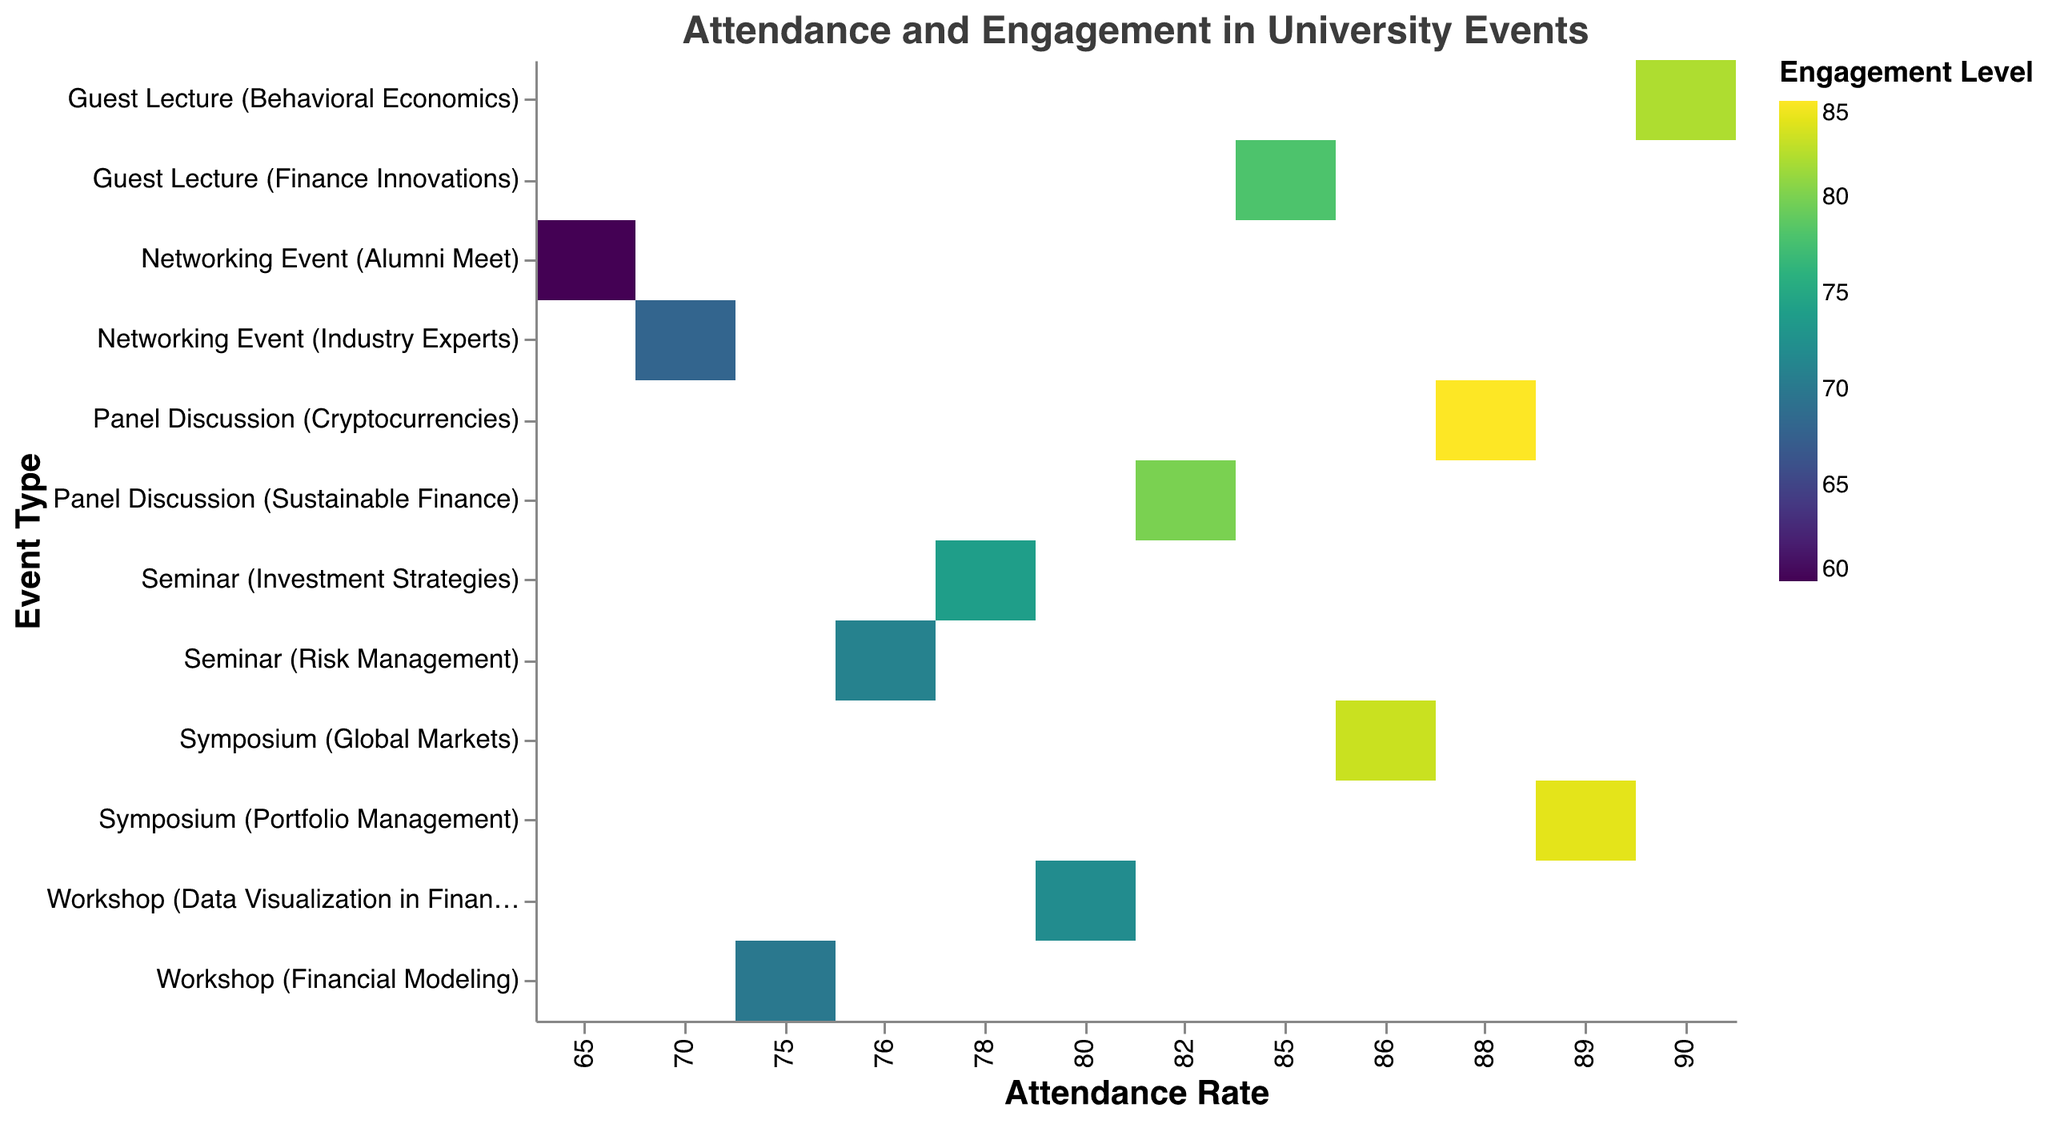What's the title of the heatmap? The title of the heatmap is located at the top and is clearly labeled. It reads "Attendance and Engagement in University Events".
Answer: Attendance and Engagement in University Events What are the axes labeled? The y-axis represents "Event Type" and lists various university events. The x-axis represents "Attendance Rate". These labels help in identifying what each axis is measuring.
Answer: Event Type (y-axis), Attendance Rate (x-axis) Which event has the highest attendance rate? By scanning the x-axis for the highest value and locating the corresponding event on the y-axis, we find that "Guest Lecture (Behavioral Economics)" has the highest attendance rate of 90.
Answer: Guest Lecture (Behavioral Economics) Which event has the lowest engagement level? By assessing the color scale and the legend, the event with the lowest engagement level corresponds to the lightest color. "Networking Event (Alumni Meet)" shows the lowest engagement level of 60.
Answer: Networking Event (Alumni Meet) Compare the engagement level of "Panel Discussion (Cryptocurrencies)" and "Panel Discussion (Sustainable Finance)". Which one is higher? By locating both events on the y-axis and comparing their colors based on the legend, "Panel Discussion (Cryptocurrencies)" has a higher engagement level of 85 compared to "Sustainable Finance" at 80.
Answer: Panel Discussion (Cryptocurrencies) What is the average engagement level of all workshops? Identify all workshops: "Financial Modeling" and "Data Visualization in Finance". Their engagement levels are 70 and 72, respectively. The average is calculated as (70+72)/2 = 71.
Answer: 71 What is the difference in attendance rate between "Symposium (Global Markets)" and "Symposium (Portfolio Management)"? The attendance rates for "Global Markets" and "Portfolio Management" are 86 and 89, respectively. The difference is 89 - 86 = 3.
Answer: 3 Which type of event, seminars or symposia, has higher average engagement levels? Seminars: Identify engagement levels for "Investment Strategies" (74) and "Risk Management" (71); average = (74+71)/2 = 72.5. Symposia: Identify engagement levels for "Global Markets" (83) and "Portfolio Management" (84); average = (83+84)/2 = 83.5.
Answer: Symposia How many data points are there in the heatmap? Each event type listed on the y-axis corresponds to one data point in the heatmap. Counting all entries results in 12 data points.
Answer: 12 Which event has the same attendance rate as "Panel Discussion (Cryptocurrencies)" but different engagement level? "Panel Discussion (Cryptocurrencies)" has an attendance rate of 88. Checking the x-axis for attendance rate of 88, we find no other event matches both the attendance rate and event type of "Panel Discussion (Cryptocurrencies)".
Answer: None 